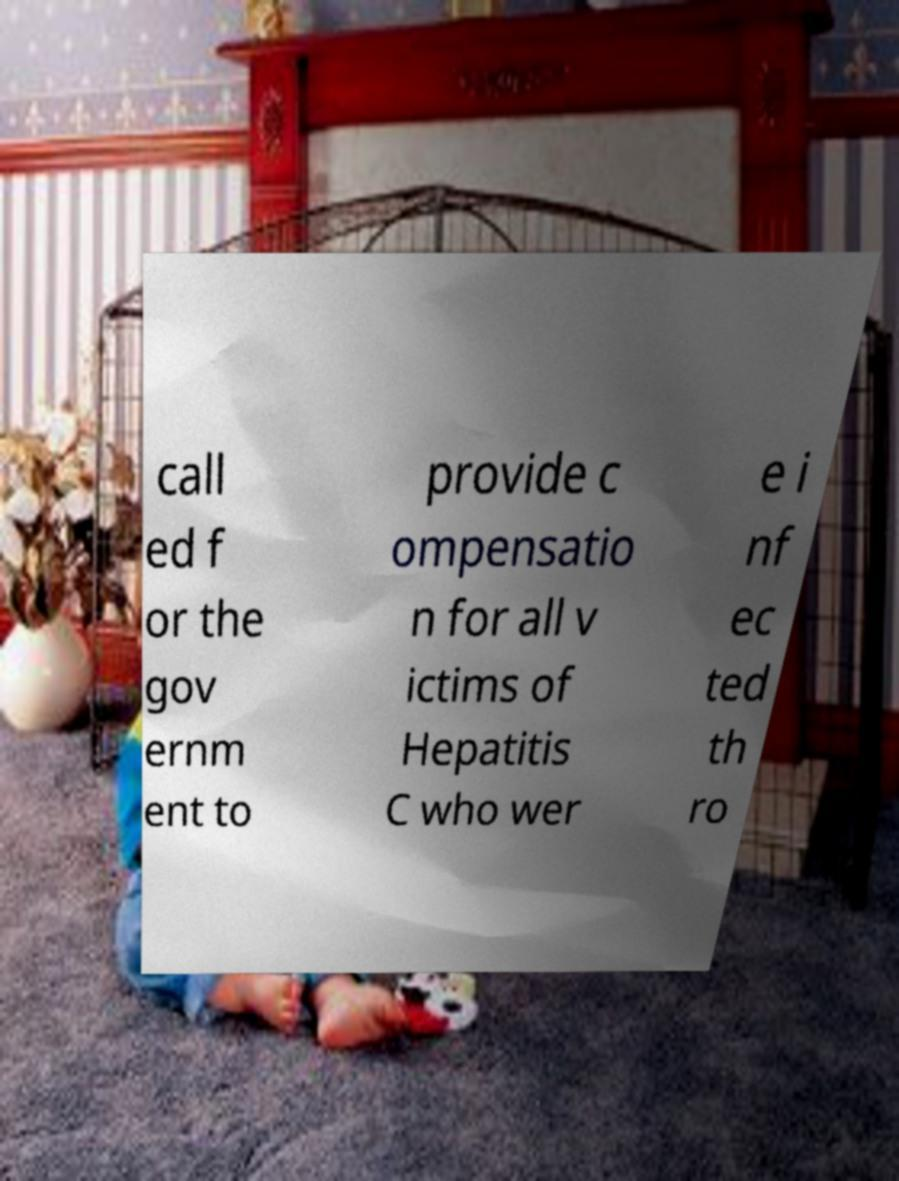I need the written content from this picture converted into text. Can you do that? call ed f or the gov ernm ent to provide c ompensatio n for all v ictims of Hepatitis C who wer e i nf ec ted th ro 